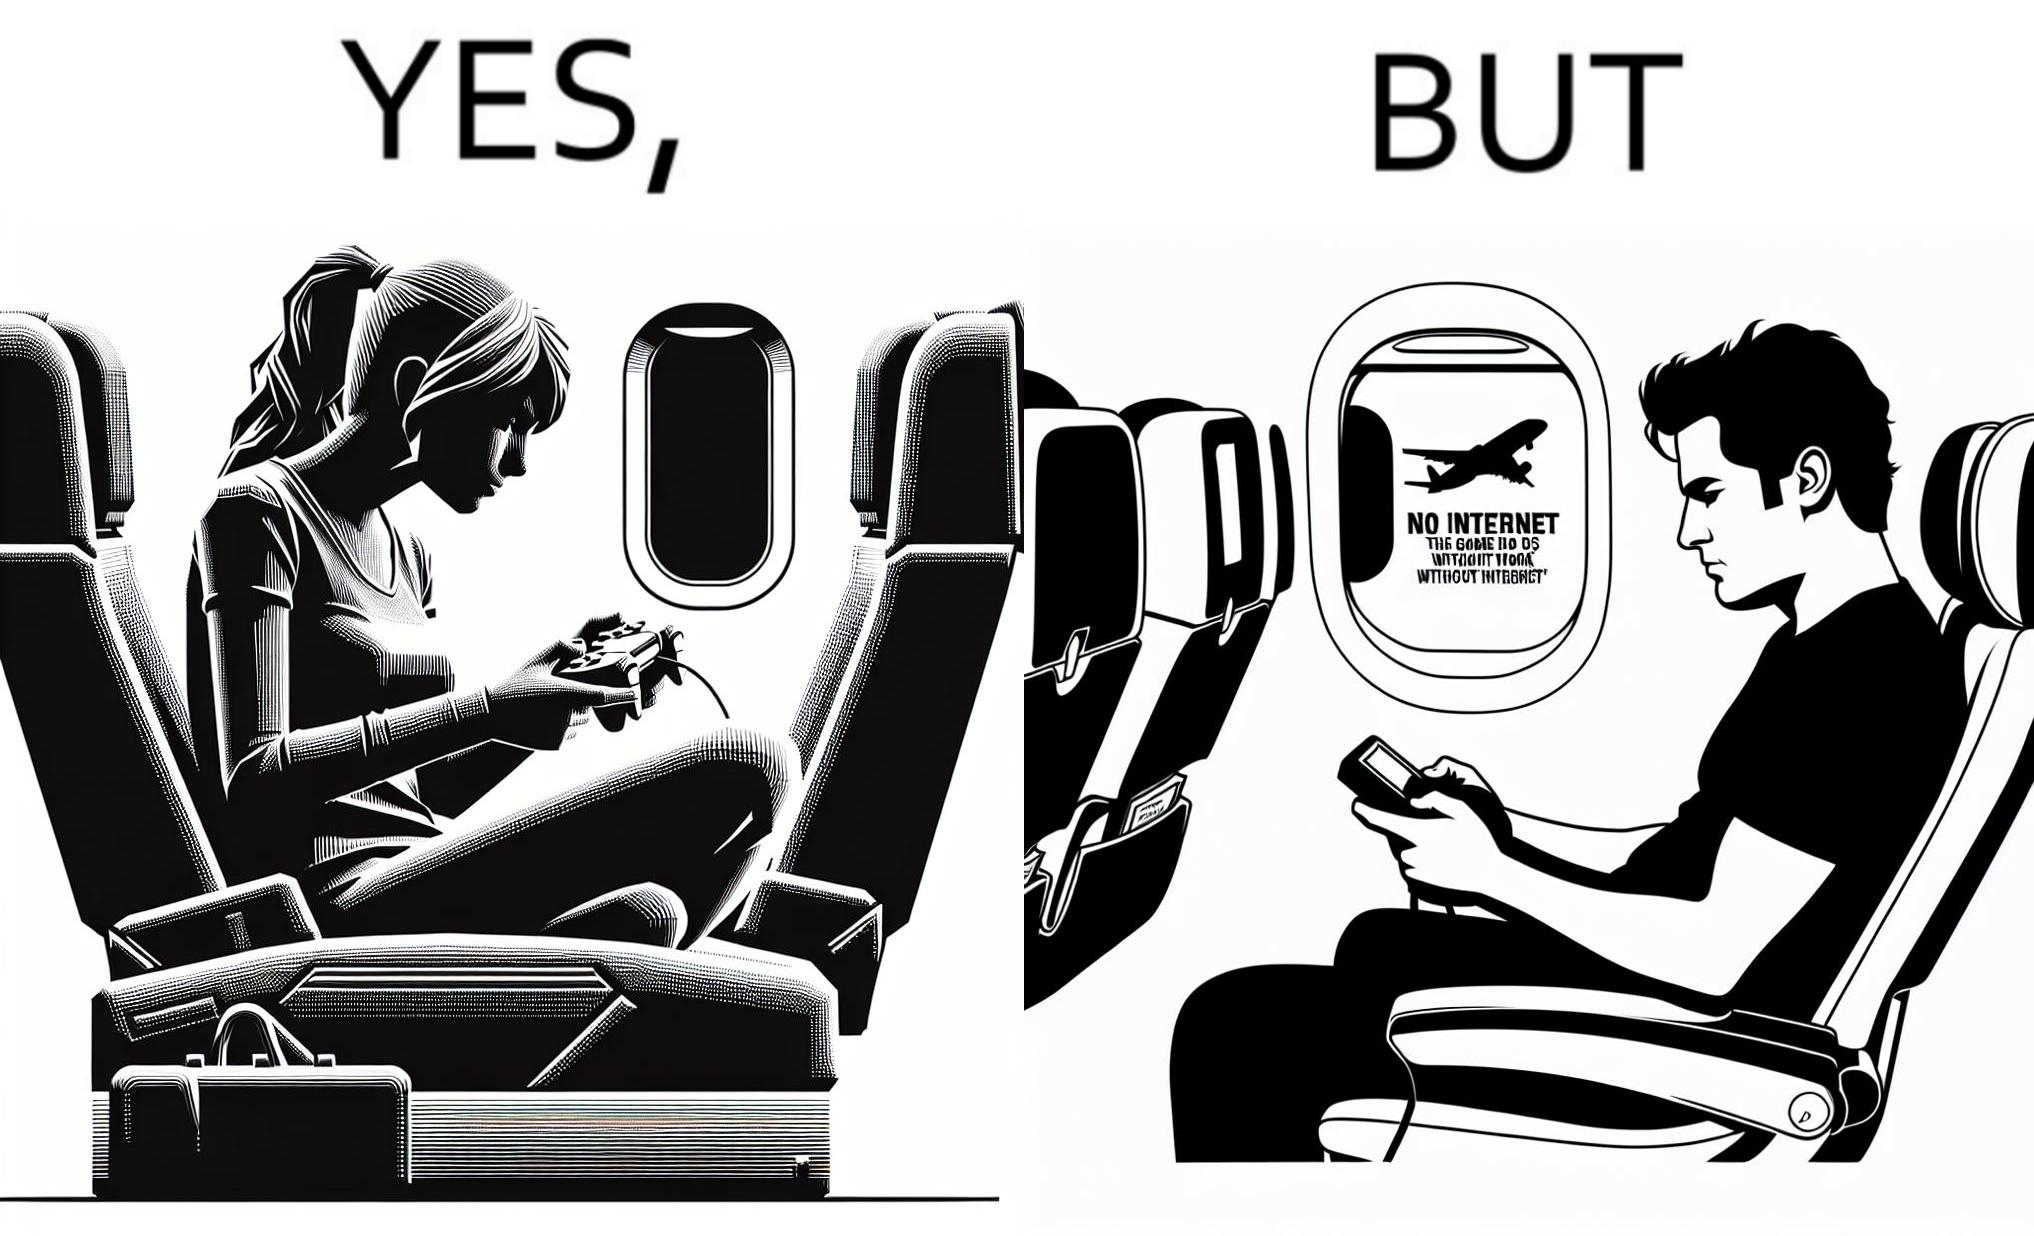What is shown in the left half versus the right half of this image? In the left part of the image: a person sitting in a flight seat, with a gaming console in the person's hands. In the right part of the image: a person sitting in a flight seat, with a gaming console in the person's hands, with a message which shows "No Internet, the game does not work without internet". 